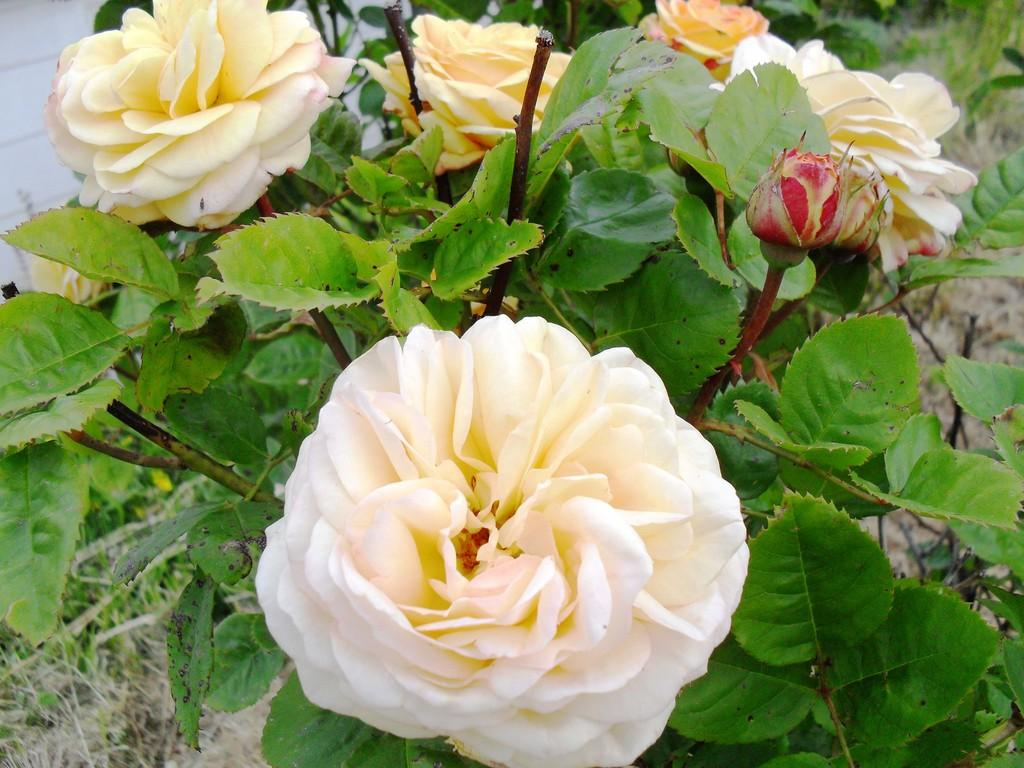What type of plants can be seen in the image? There are plants with flowers in the image. What type of vegetation is visible in the image? There is grass visible in the image. What shape is the celery in the image? There is no celery present in the image. Is there a scarecrow standing among the plants in the image? There is no scarecrow present in the image. 